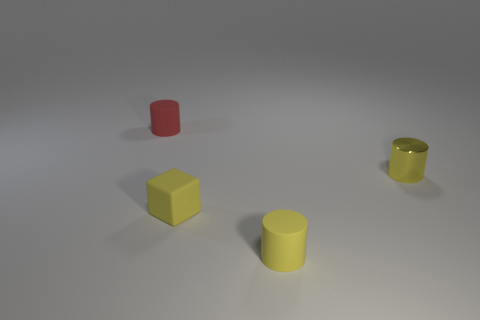Add 4 yellow matte blocks. How many objects exist? 8 Subtract all blocks. How many objects are left? 3 Subtract 0 cyan cylinders. How many objects are left? 4 Subtract all small objects. Subtract all big brown cylinders. How many objects are left? 0 Add 4 small shiny objects. How many small shiny objects are left? 5 Add 3 small yellow objects. How many small yellow objects exist? 6 